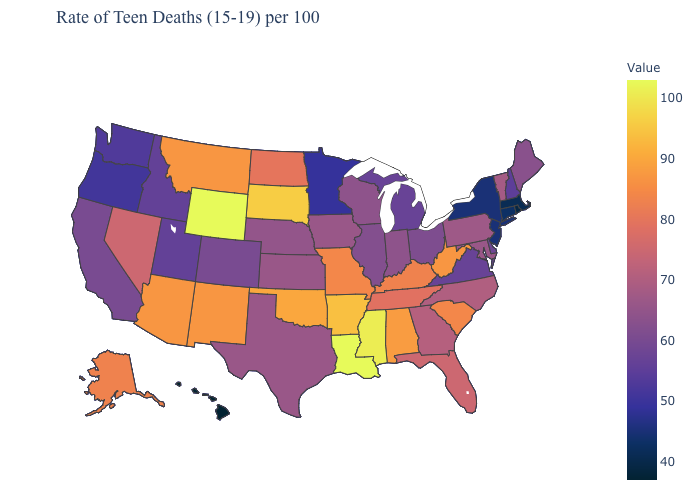Does Kansas have the lowest value in the MidWest?
Give a very brief answer. No. Among the states that border Virginia , which have the highest value?
Concise answer only. West Virginia. Among the states that border Tennessee , does Arkansas have the lowest value?
Short answer required. No. Is the legend a continuous bar?
Give a very brief answer. Yes. Does the map have missing data?
Short answer required. No. Is the legend a continuous bar?
Write a very short answer. Yes. Among the states that border Washington , does Idaho have the lowest value?
Quick response, please. No. 